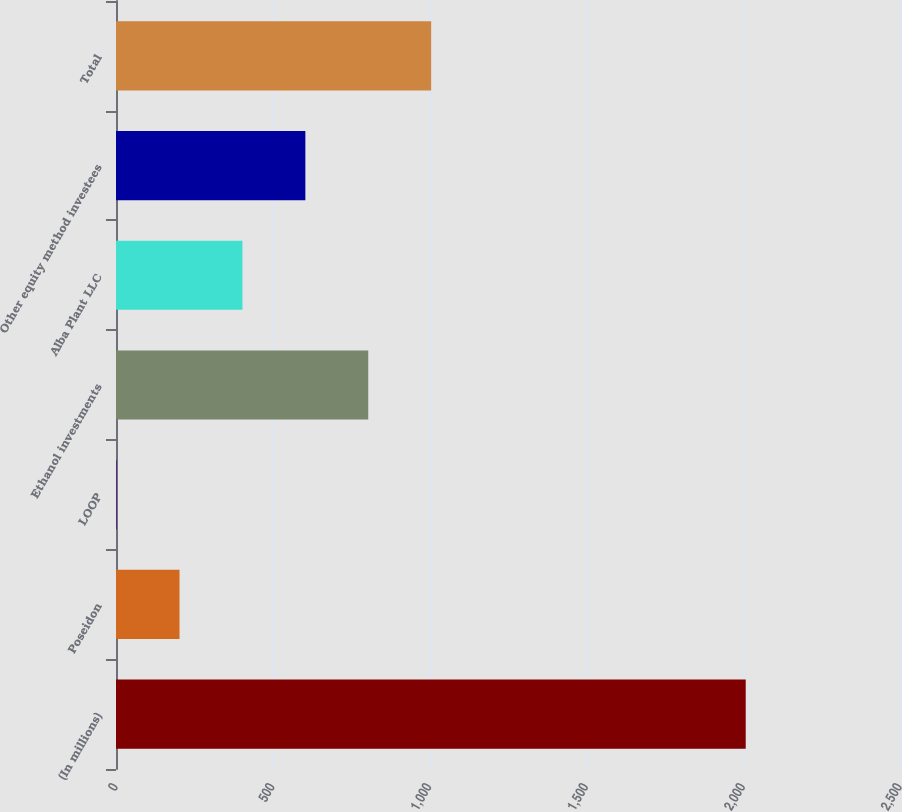<chart> <loc_0><loc_0><loc_500><loc_500><bar_chart><fcel>(In millions)<fcel>Poseidon<fcel>LOOP<fcel>Ethanol investments<fcel>Alba Plant LLC<fcel>Other equity method investees<fcel>Total<nl><fcel>2008<fcel>202.6<fcel>2<fcel>804.4<fcel>403.2<fcel>603.8<fcel>1005<nl></chart> 